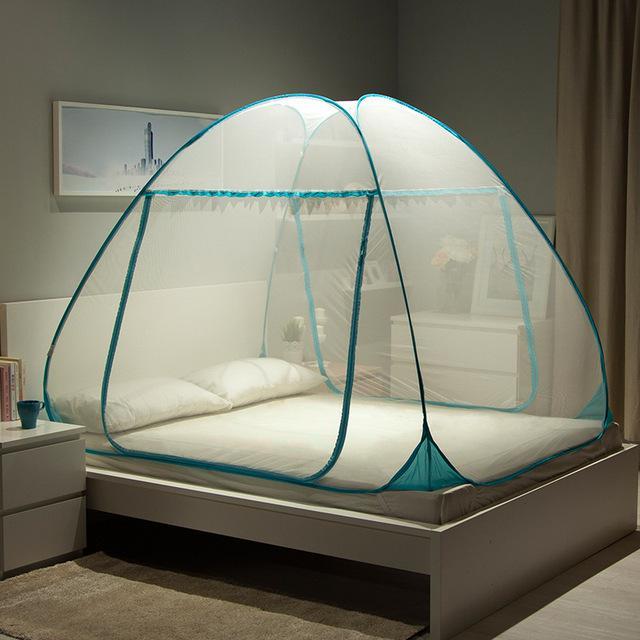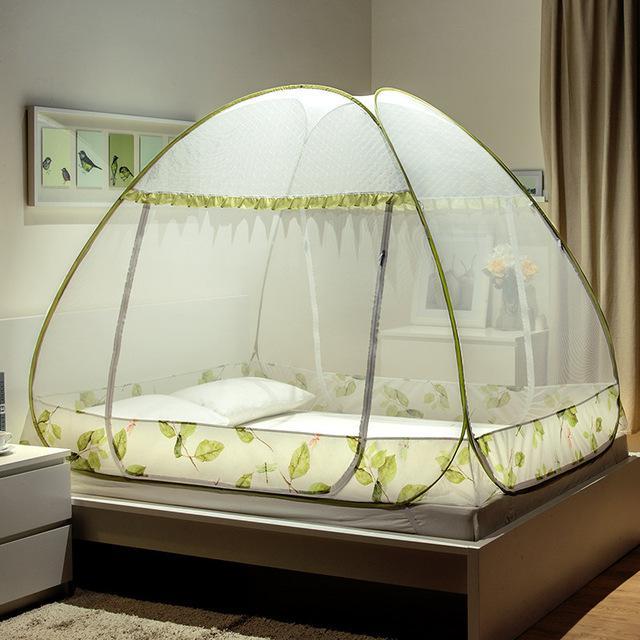The first image is the image on the left, the second image is the image on the right. For the images shown, is this caption "There are two tent canopies with at least one with blue trim that has a pattern around the bottom of the tent." true? Answer yes or no. No. The first image is the image on the left, the second image is the image on the right. For the images shown, is this caption "In the right image exactly one net has a cloth trim on the bottom." true? Answer yes or no. Yes. 